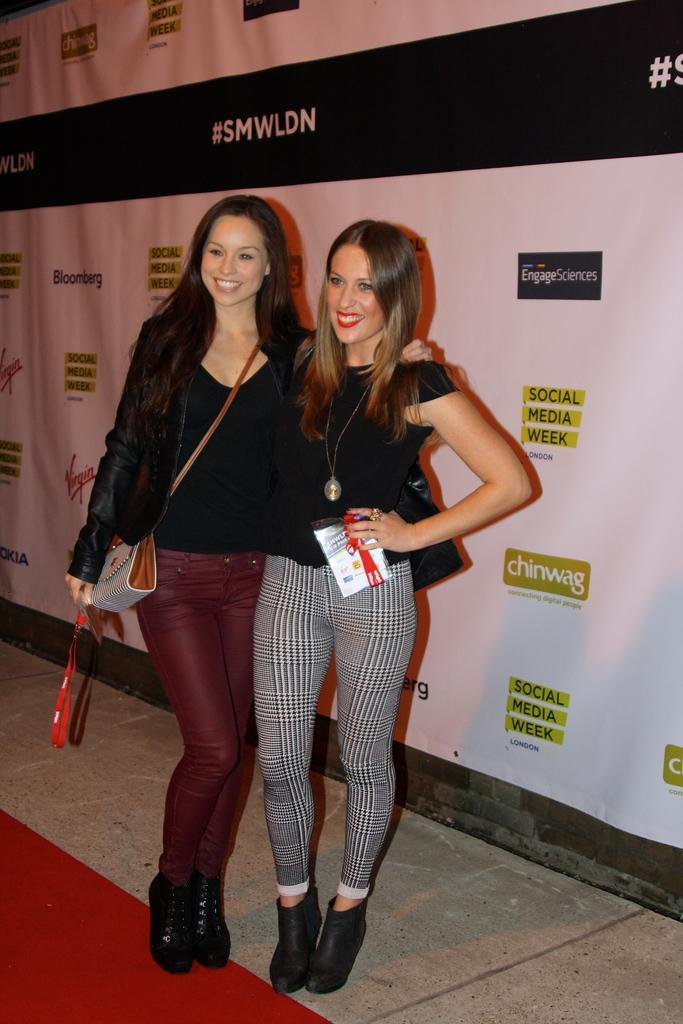How many people are in the image? There are two women in the image. What are the women doing in the image? The women are standing and smiling. What can be seen in the background of the image? There is a banner in the background of the image. What is on the floor at the bottom of the image? There is a red carpet on the floor at the bottom of the image. How many cows are visible in the image? There are no cows present in the image. What is the relationship between the women and the person referred to as "aunt" in the image? There is no mention of an "aunt" in the image, so we cannot determine the relationship between the women and an aunt. 